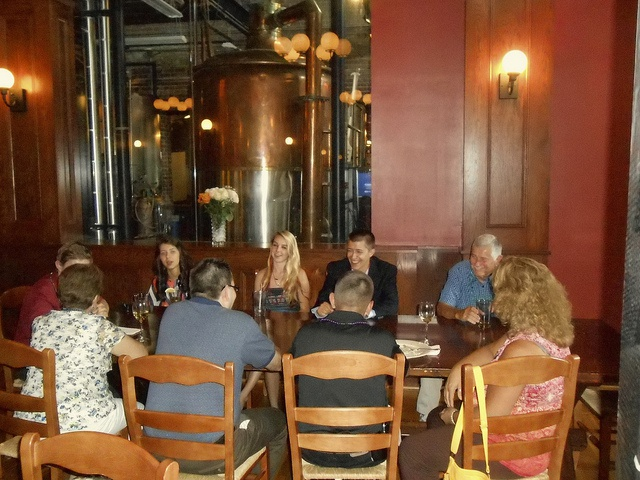Describe the objects in this image and their specific colors. I can see people in maroon and gray tones, people in maroon, brown, gray, and tan tones, chair in maroon, tan, black, and red tones, chair in maroon, brown, and gray tones, and chair in maroon, red, tan, and salmon tones in this image. 